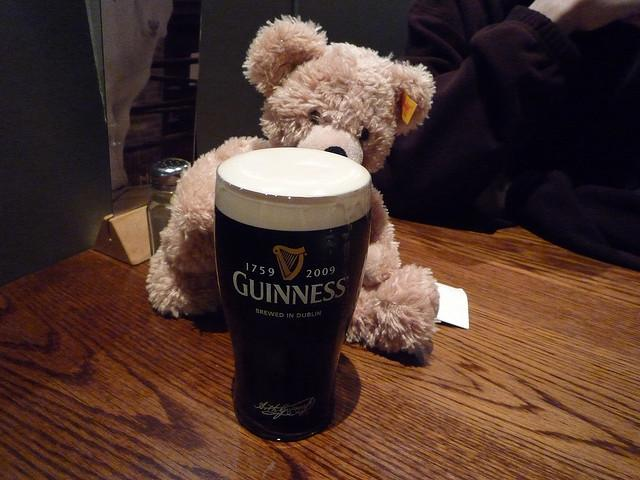What plant adds bitterness to this beverage?

Choices:
A) hops
B) corn
C) mugwort
D) sugar hops 